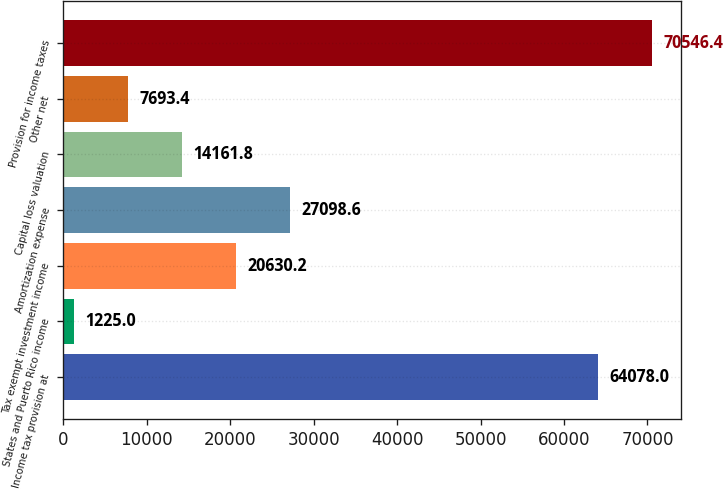Convert chart. <chart><loc_0><loc_0><loc_500><loc_500><bar_chart><fcel>Income tax provision at<fcel>States and Puerto Rico income<fcel>Tax exempt investment income<fcel>Amortization expense<fcel>Capital loss valuation<fcel>Other net<fcel>Provision for income taxes<nl><fcel>64078<fcel>1225<fcel>20630.2<fcel>27098.6<fcel>14161.8<fcel>7693.4<fcel>70546.4<nl></chart> 